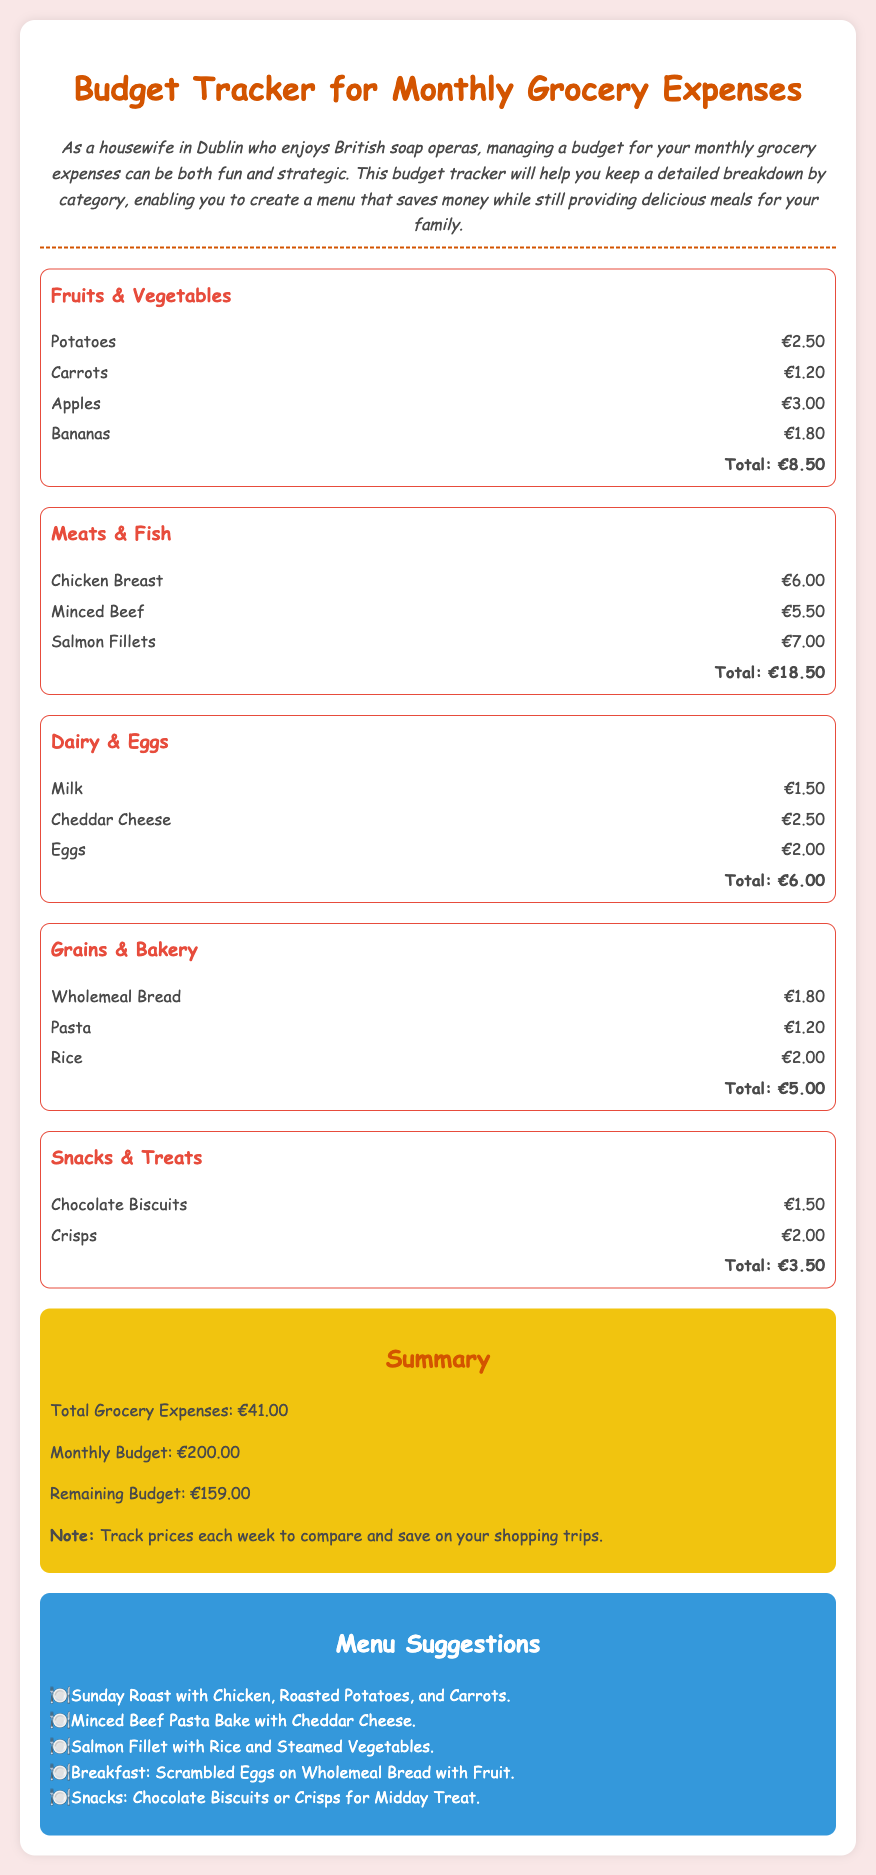What is the total expense for Fruits & Vegetables? The total expense for Fruits & Vegetables is listed in the document under that category as €8.50.
Answer: €8.50 What is the total expense for Meats & Fish? The total expense for Meats & Fish is provided in the document as €18.50.
Answer: €18.50 How much is the remaining budget? The remaining budget is calculated from the monthly budget minus total grocery expenses, which is €200.00 - €41.00 in the document.
Answer: €159.00 What is the total grocery expense? The total grocery expense is given as the cumulative total of all categories, which is €41.00 in the document.
Answer: €41.00 Which item costs €2.50 in Dairy & Eggs? The item that costs €2.50 in Dairy & Eggs can be found in the document as Cheddar Cheese.
Answer: Cheddar Cheese How many menu suggestions are provided? The number of menu suggestions can be counted in the section, which lists five different ideas in the document.
Answer: 5 What is one suggested meal that includes salmon? The suggested meal that includes salmon is described in the document as "Salmon Fillet with Rice and Steamed Vegetables."
Answer: Salmon Fillet with Rice and Steamed Vegetables What is the budget tracker primarily used for? The budget tracker is primarily used for managing monthly grocery expenses as stated in the document.
Answer: Monthly grocery expenses 